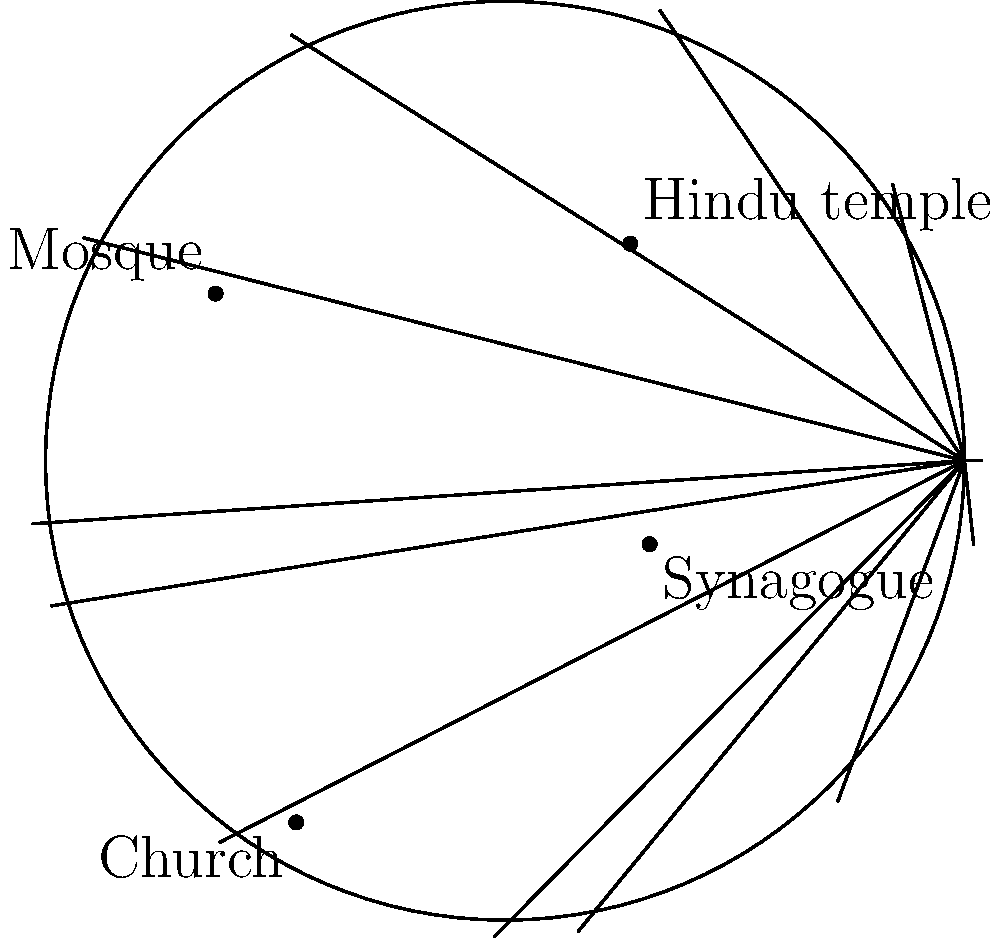In a multicultural neighborhood, various religious landmarks are represented on a polar grid. The Hindu temple is located at $(3, 60°)$, the Mosque at $(4, 150°)$, the Church at $(5, 240°)$, and the Synagogue at $(2, 330°)$. Calculate the distance between the Hindu temple and the Church, rounded to two decimal places. To find the distance between two points in polar coordinates, we can use the following steps:

1. Convert the polar coordinates to Cartesian coordinates:
   Hindu temple $(3, 60°)$:
   $x_1 = 3 \cos(60°) = 1.5$
   $y_1 = 3 \sin(60°) = 2.60$

   Church $(5, 240°)$:
   $x_2 = 5 \cos(240°) = -2.5$
   $y_2 = 5 \sin(240°) = -4.33$

2. Use the distance formula for Cartesian coordinates:
   $d = \sqrt{(x_2 - x_1)^2 + (y_2 - y_1)^2}$

3. Substitute the values:
   $d = \sqrt{(-2.5 - 1.5)^2 + (-4.33 - 2.60)^2}$
   $d = \sqrt{(-4)^2 + (-6.93)^2}$
   $d = \sqrt{16 + 48.0249}$
   $d = \sqrt{64.0249}$
   $d \approx 8.0015$

4. Round to two decimal places:
   $d \approx 8.00$

Therefore, the distance between the Hindu temple and the Church is approximately 8.00 units.
Answer: 8.00 units 